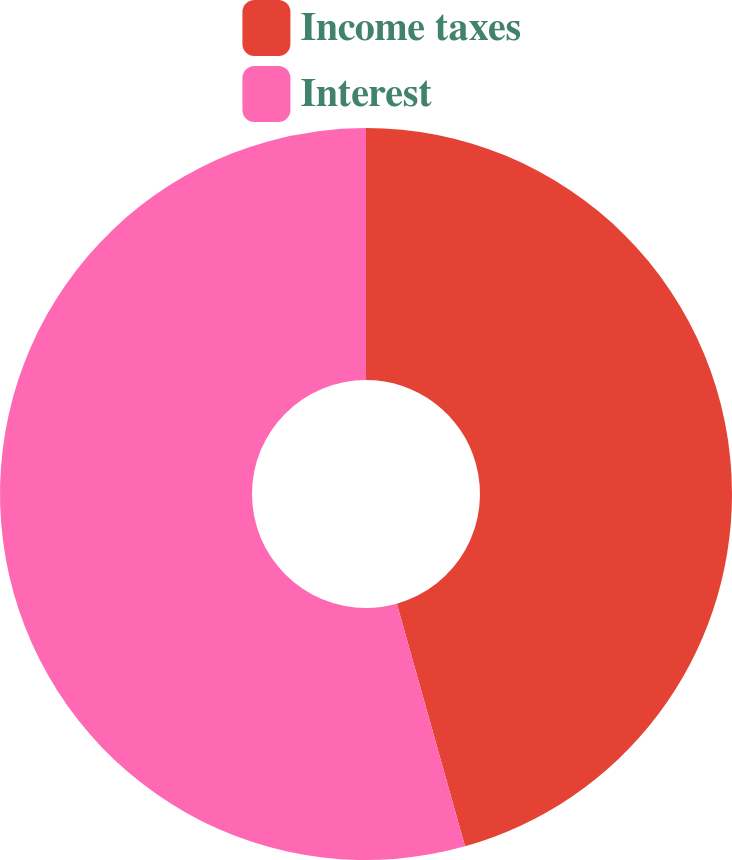Convert chart to OTSL. <chart><loc_0><loc_0><loc_500><loc_500><pie_chart><fcel>Income taxes<fcel>Interest<nl><fcel>45.64%<fcel>54.36%<nl></chart> 